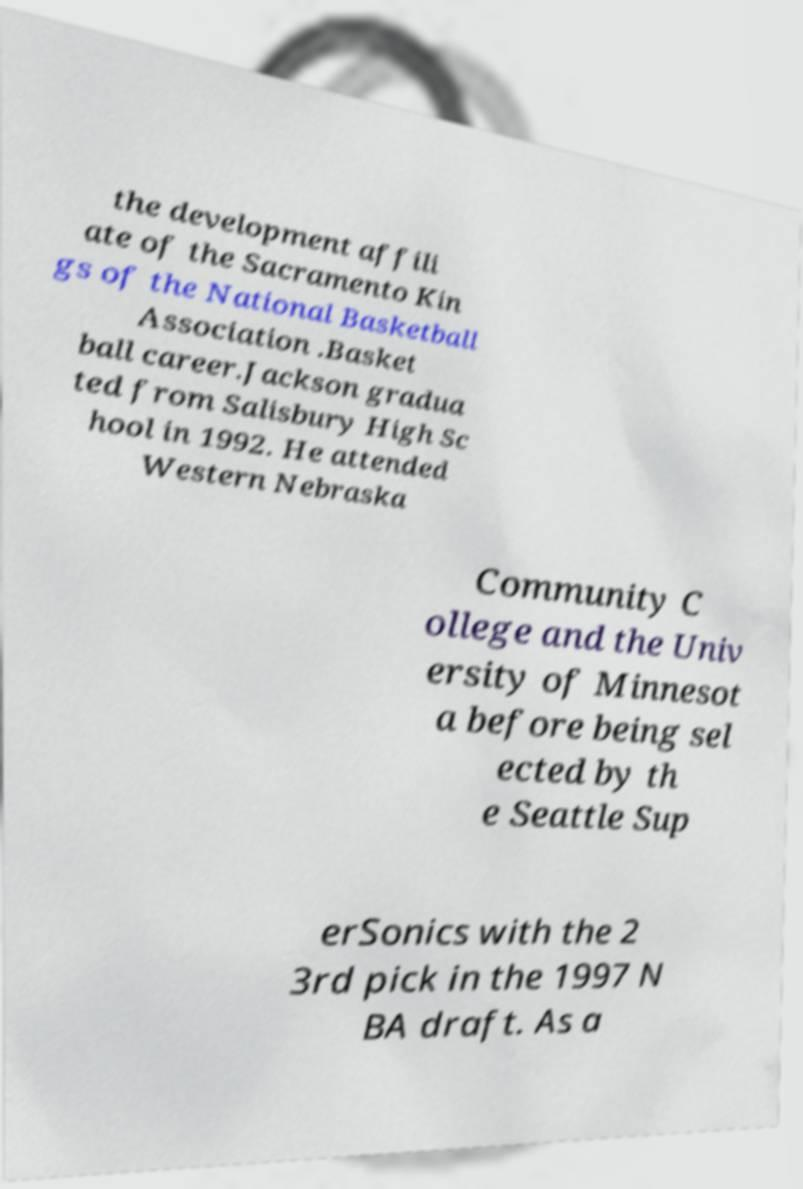What messages or text are displayed in this image? I need them in a readable, typed format. the development affili ate of the Sacramento Kin gs of the National Basketball Association .Basket ball career.Jackson gradua ted from Salisbury High Sc hool in 1992. He attended Western Nebraska Community C ollege and the Univ ersity of Minnesot a before being sel ected by th e Seattle Sup erSonics with the 2 3rd pick in the 1997 N BA draft. As a 